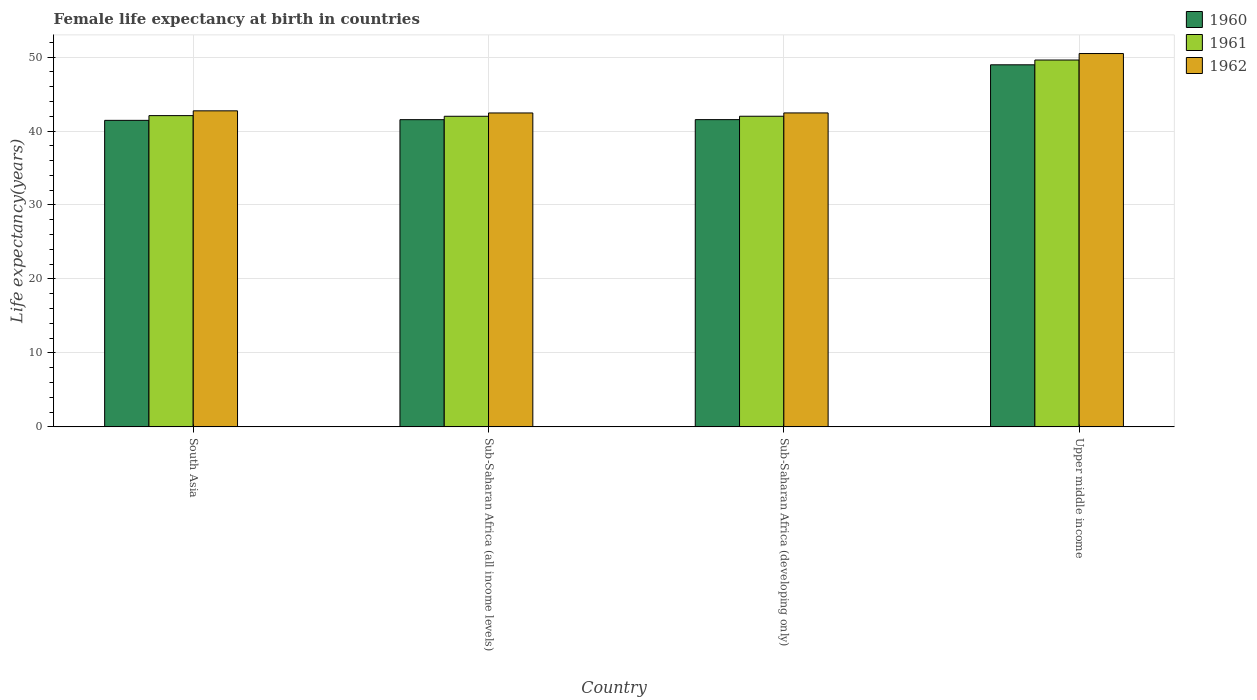Are the number of bars on each tick of the X-axis equal?
Your response must be concise. Yes. How many bars are there on the 3rd tick from the right?
Your answer should be compact. 3. What is the label of the 4th group of bars from the left?
Make the answer very short. Upper middle income. What is the female life expectancy at birth in 1960 in Upper middle income?
Your answer should be compact. 48.95. Across all countries, what is the maximum female life expectancy at birth in 1962?
Your response must be concise. 50.48. Across all countries, what is the minimum female life expectancy at birth in 1961?
Ensure brevity in your answer.  42. In which country was the female life expectancy at birth in 1960 maximum?
Your answer should be compact. Upper middle income. What is the total female life expectancy at birth in 1962 in the graph?
Give a very brief answer. 178.1. What is the difference between the female life expectancy at birth in 1960 in South Asia and that in Upper middle income?
Your answer should be compact. -7.51. What is the difference between the female life expectancy at birth in 1962 in Upper middle income and the female life expectancy at birth in 1961 in South Asia?
Ensure brevity in your answer.  8.39. What is the average female life expectancy at birth in 1961 per country?
Provide a short and direct response. 43.92. What is the difference between the female life expectancy at birth of/in 1960 and female life expectancy at birth of/in 1962 in South Asia?
Make the answer very short. -1.29. In how many countries, is the female life expectancy at birth in 1962 greater than 50 years?
Give a very brief answer. 1. What is the ratio of the female life expectancy at birth in 1962 in Sub-Saharan Africa (all income levels) to that in Upper middle income?
Make the answer very short. 0.84. Is the female life expectancy at birth in 1960 in South Asia less than that in Sub-Saharan Africa (all income levels)?
Your answer should be very brief. Yes. What is the difference between the highest and the second highest female life expectancy at birth in 1961?
Give a very brief answer. 7.52. What is the difference between the highest and the lowest female life expectancy at birth in 1962?
Keep it short and to the point. 8.03. In how many countries, is the female life expectancy at birth in 1961 greater than the average female life expectancy at birth in 1961 taken over all countries?
Offer a terse response. 1. What does the 1st bar from the right in Upper middle income represents?
Your answer should be very brief. 1962. How many bars are there?
Provide a short and direct response. 12. Are all the bars in the graph horizontal?
Give a very brief answer. No. Are the values on the major ticks of Y-axis written in scientific E-notation?
Make the answer very short. No. Does the graph contain any zero values?
Your answer should be compact. No. Does the graph contain grids?
Give a very brief answer. Yes. How are the legend labels stacked?
Provide a succinct answer. Vertical. What is the title of the graph?
Give a very brief answer. Female life expectancy at birth in countries. What is the label or title of the Y-axis?
Offer a very short reply. Life expectancy(years). What is the Life expectancy(years) of 1960 in South Asia?
Keep it short and to the point. 41.44. What is the Life expectancy(years) in 1961 in South Asia?
Offer a very short reply. 42.08. What is the Life expectancy(years) in 1962 in South Asia?
Your answer should be very brief. 42.73. What is the Life expectancy(years) of 1960 in Sub-Saharan Africa (all income levels)?
Make the answer very short. 41.54. What is the Life expectancy(years) of 1961 in Sub-Saharan Africa (all income levels)?
Your answer should be very brief. 42. What is the Life expectancy(years) of 1962 in Sub-Saharan Africa (all income levels)?
Your response must be concise. 42.44. What is the Life expectancy(years) in 1960 in Sub-Saharan Africa (developing only)?
Your response must be concise. 41.54. What is the Life expectancy(years) in 1961 in Sub-Saharan Africa (developing only)?
Provide a short and direct response. 42. What is the Life expectancy(years) of 1962 in Sub-Saharan Africa (developing only)?
Your answer should be very brief. 42.45. What is the Life expectancy(years) of 1960 in Upper middle income?
Offer a terse response. 48.95. What is the Life expectancy(years) in 1961 in Upper middle income?
Offer a terse response. 49.6. What is the Life expectancy(years) in 1962 in Upper middle income?
Offer a terse response. 50.48. Across all countries, what is the maximum Life expectancy(years) in 1960?
Your response must be concise. 48.95. Across all countries, what is the maximum Life expectancy(years) in 1961?
Make the answer very short. 49.6. Across all countries, what is the maximum Life expectancy(years) of 1962?
Your answer should be very brief. 50.48. Across all countries, what is the minimum Life expectancy(years) in 1960?
Give a very brief answer. 41.44. Across all countries, what is the minimum Life expectancy(years) of 1961?
Provide a short and direct response. 42. Across all countries, what is the minimum Life expectancy(years) of 1962?
Your response must be concise. 42.44. What is the total Life expectancy(years) of 1960 in the graph?
Keep it short and to the point. 173.48. What is the total Life expectancy(years) of 1961 in the graph?
Provide a succinct answer. 175.68. What is the total Life expectancy(years) in 1962 in the graph?
Keep it short and to the point. 178.1. What is the difference between the Life expectancy(years) in 1960 in South Asia and that in Sub-Saharan Africa (all income levels)?
Provide a succinct answer. -0.09. What is the difference between the Life expectancy(years) of 1961 in South Asia and that in Sub-Saharan Africa (all income levels)?
Your answer should be very brief. 0.09. What is the difference between the Life expectancy(years) in 1962 in South Asia and that in Sub-Saharan Africa (all income levels)?
Your answer should be very brief. 0.29. What is the difference between the Life expectancy(years) of 1960 in South Asia and that in Sub-Saharan Africa (developing only)?
Offer a terse response. -0.1. What is the difference between the Life expectancy(years) of 1961 in South Asia and that in Sub-Saharan Africa (developing only)?
Ensure brevity in your answer.  0.08. What is the difference between the Life expectancy(years) of 1962 in South Asia and that in Sub-Saharan Africa (developing only)?
Offer a terse response. 0.28. What is the difference between the Life expectancy(years) in 1960 in South Asia and that in Upper middle income?
Your answer should be compact. -7.51. What is the difference between the Life expectancy(years) of 1961 in South Asia and that in Upper middle income?
Your response must be concise. -7.52. What is the difference between the Life expectancy(years) of 1962 in South Asia and that in Upper middle income?
Keep it short and to the point. -7.75. What is the difference between the Life expectancy(years) in 1960 in Sub-Saharan Africa (all income levels) and that in Sub-Saharan Africa (developing only)?
Your response must be concise. -0. What is the difference between the Life expectancy(years) in 1961 in Sub-Saharan Africa (all income levels) and that in Sub-Saharan Africa (developing only)?
Your response must be concise. -0. What is the difference between the Life expectancy(years) of 1962 in Sub-Saharan Africa (all income levels) and that in Sub-Saharan Africa (developing only)?
Your answer should be compact. -0. What is the difference between the Life expectancy(years) in 1960 in Sub-Saharan Africa (all income levels) and that in Upper middle income?
Ensure brevity in your answer.  -7.42. What is the difference between the Life expectancy(years) of 1961 in Sub-Saharan Africa (all income levels) and that in Upper middle income?
Provide a short and direct response. -7.6. What is the difference between the Life expectancy(years) of 1962 in Sub-Saharan Africa (all income levels) and that in Upper middle income?
Your response must be concise. -8.03. What is the difference between the Life expectancy(years) in 1960 in Sub-Saharan Africa (developing only) and that in Upper middle income?
Make the answer very short. -7.41. What is the difference between the Life expectancy(years) in 1961 in Sub-Saharan Africa (developing only) and that in Upper middle income?
Provide a succinct answer. -7.6. What is the difference between the Life expectancy(years) in 1962 in Sub-Saharan Africa (developing only) and that in Upper middle income?
Offer a very short reply. -8.03. What is the difference between the Life expectancy(years) of 1960 in South Asia and the Life expectancy(years) of 1961 in Sub-Saharan Africa (all income levels)?
Your answer should be compact. -0.55. What is the difference between the Life expectancy(years) of 1960 in South Asia and the Life expectancy(years) of 1962 in Sub-Saharan Africa (all income levels)?
Ensure brevity in your answer.  -1. What is the difference between the Life expectancy(years) of 1961 in South Asia and the Life expectancy(years) of 1962 in Sub-Saharan Africa (all income levels)?
Ensure brevity in your answer.  -0.36. What is the difference between the Life expectancy(years) in 1960 in South Asia and the Life expectancy(years) in 1961 in Sub-Saharan Africa (developing only)?
Provide a short and direct response. -0.56. What is the difference between the Life expectancy(years) of 1960 in South Asia and the Life expectancy(years) of 1962 in Sub-Saharan Africa (developing only)?
Keep it short and to the point. -1. What is the difference between the Life expectancy(years) in 1961 in South Asia and the Life expectancy(years) in 1962 in Sub-Saharan Africa (developing only)?
Make the answer very short. -0.36. What is the difference between the Life expectancy(years) in 1960 in South Asia and the Life expectancy(years) in 1961 in Upper middle income?
Make the answer very short. -8.16. What is the difference between the Life expectancy(years) in 1960 in South Asia and the Life expectancy(years) in 1962 in Upper middle income?
Make the answer very short. -9.03. What is the difference between the Life expectancy(years) in 1961 in South Asia and the Life expectancy(years) in 1962 in Upper middle income?
Provide a succinct answer. -8.39. What is the difference between the Life expectancy(years) of 1960 in Sub-Saharan Africa (all income levels) and the Life expectancy(years) of 1961 in Sub-Saharan Africa (developing only)?
Provide a short and direct response. -0.46. What is the difference between the Life expectancy(years) of 1960 in Sub-Saharan Africa (all income levels) and the Life expectancy(years) of 1962 in Sub-Saharan Africa (developing only)?
Make the answer very short. -0.91. What is the difference between the Life expectancy(years) in 1961 in Sub-Saharan Africa (all income levels) and the Life expectancy(years) in 1962 in Sub-Saharan Africa (developing only)?
Your answer should be very brief. -0.45. What is the difference between the Life expectancy(years) in 1960 in Sub-Saharan Africa (all income levels) and the Life expectancy(years) in 1961 in Upper middle income?
Provide a short and direct response. -8.06. What is the difference between the Life expectancy(years) in 1960 in Sub-Saharan Africa (all income levels) and the Life expectancy(years) in 1962 in Upper middle income?
Offer a terse response. -8.94. What is the difference between the Life expectancy(years) in 1961 in Sub-Saharan Africa (all income levels) and the Life expectancy(years) in 1962 in Upper middle income?
Offer a very short reply. -8.48. What is the difference between the Life expectancy(years) of 1960 in Sub-Saharan Africa (developing only) and the Life expectancy(years) of 1961 in Upper middle income?
Your answer should be very brief. -8.06. What is the difference between the Life expectancy(years) of 1960 in Sub-Saharan Africa (developing only) and the Life expectancy(years) of 1962 in Upper middle income?
Your answer should be very brief. -8.94. What is the difference between the Life expectancy(years) of 1961 in Sub-Saharan Africa (developing only) and the Life expectancy(years) of 1962 in Upper middle income?
Ensure brevity in your answer.  -8.48. What is the average Life expectancy(years) in 1960 per country?
Your response must be concise. 43.37. What is the average Life expectancy(years) of 1961 per country?
Provide a short and direct response. 43.92. What is the average Life expectancy(years) in 1962 per country?
Ensure brevity in your answer.  44.52. What is the difference between the Life expectancy(years) in 1960 and Life expectancy(years) in 1961 in South Asia?
Keep it short and to the point. -0.64. What is the difference between the Life expectancy(years) of 1960 and Life expectancy(years) of 1962 in South Asia?
Offer a very short reply. -1.29. What is the difference between the Life expectancy(years) of 1961 and Life expectancy(years) of 1962 in South Asia?
Your answer should be very brief. -0.65. What is the difference between the Life expectancy(years) in 1960 and Life expectancy(years) in 1961 in Sub-Saharan Africa (all income levels)?
Your answer should be compact. -0.46. What is the difference between the Life expectancy(years) of 1960 and Life expectancy(years) of 1962 in Sub-Saharan Africa (all income levels)?
Provide a succinct answer. -0.91. What is the difference between the Life expectancy(years) of 1961 and Life expectancy(years) of 1962 in Sub-Saharan Africa (all income levels)?
Provide a short and direct response. -0.45. What is the difference between the Life expectancy(years) in 1960 and Life expectancy(years) in 1961 in Sub-Saharan Africa (developing only)?
Provide a succinct answer. -0.46. What is the difference between the Life expectancy(years) of 1960 and Life expectancy(years) of 1962 in Sub-Saharan Africa (developing only)?
Ensure brevity in your answer.  -0.91. What is the difference between the Life expectancy(years) in 1961 and Life expectancy(years) in 1962 in Sub-Saharan Africa (developing only)?
Give a very brief answer. -0.45. What is the difference between the Life expectancy(years) in 1960 and Life expectancy(years) in 1961 in Upper middle income?
Offer a terse response. -0.65. What is the difference between the Life expectancy(years) of 1960 and Life expectancy(years) of 1962 in Upper middle income?
Make the answer very short. -1.52. What is the difference between the Life expectancy(years) in 1961 and Life expectancy(years) in 1962 in Upper middle income?
Give a very brief answer. -0.88. What is the ratio of the Life expectancy(years) of 1961 in South Asia to that in Sub-Saharan Africa (all income levels)?
Make the answer very short. 1. What is the ratio of the Life expectancy(years) of 1962 in South Asia to that in Sub-Saharan Africa (all income levels)?
Provide a succinct answer. 1.01. What is the ratio of the Life expectancy(years) of 1960 in South Asia to that in Sub-Saharan Africa (developing only)?
Your answer should be compact. 1. What is the ratio of the Life expectancy(years) in 1961 in South Asia to that in Sub-Saharan Africa (developing only)?
Offer a terse response. 1. What is the ratio of the Life expectancy(years) of 1962 in South Asia to that in Sub-Saharan Africa (developing only)?
Your answer should be compact. 1.01. What is the ratio of the Life expectancy(years) of 1960 in South Asia to that in Upper middle income?
Your answer should be compact. 0.85. What is the ratio of the Life expectancy(years) of 1961 in South Asia to that in Upper middle income?
Your answer should be compact. 0.85. What is the ratio of the Life expectancy(years) of 1962 in South Asia to that in Upper middle income?
Your answer should be compact. 0.85. What is the ratio of the Life expectancy(years) of 1961 in Sub-Saharan Africa (all income levels) to that in Sub-Saharan Africa (developing only)?
Your answer should be very brief. 1. What is the ratio of the Life expectancy(years) of 1960 in Sub-Saharan Africa (all income levels) to that in Upper middle income?
Make the answer very short. 0.85. What is the ratio of the Life expectancy(years) of 1961 in Sub-Saharan Africa (all income levels) to that in Upper middle income?
Offer a terse response. 0.85. What is the ratio of the Life expectancy(years) of 1962 in Sub-Saharan Africa (all income levels) to that in Upper middle income?
Offer a very short reply. 0.84. What is the ratio of the Life expectancy(years) in 1960 in Sub-Saharan Africa (developing only) to that in Upper middle income?
Your answer should be compact. 0.85. What is the ratio of the Life expectancy(years) of 1961 in Sub-Saharan Africa (developing only) to that in Upper middle income?
Your answer should be very brief. 0.85. What is the ratio of the Life expectancy(years) in 1962 in Sub-Saharan Africa (developing only) to that in Upper middle income?
Make the answer very short. 0.84. What is the difference between the highest and the second highest Life expectancy(years) of 1960?
Make the answer very short. 7.41. What is the difference between the highest and the second highest Life expectancy(years) of 1961?
Make the answer very short. 7.52. What is the difference between the highest and the second highest Life expectancy(years) of 1962?
Make the answer very short. 7.75. What is the difference between the highest and the lowest Life expectancy(years) of 1960?
Your answer should be compact. 7.51. What is the difference between the highest and the lowest Life expectancy(years) of 1961?
Your answer should be compact. 7.6. What is the difference between the highest and the lowest Life expectancy(years) of 1962?
Keep it short and to the point. 8.03. 